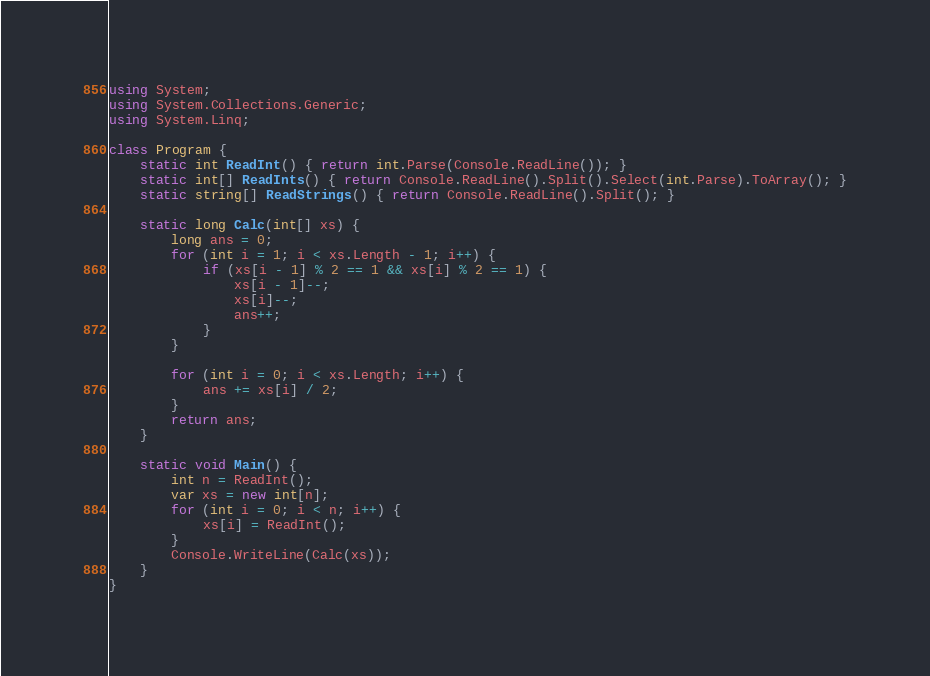<code> <loc_0><loc_0><loc_500><loc_500><_C#_>using System;
using System.Collections.Generic;
using System.Linq;

class Program {
    static int ReadInt() { return int.Parse(Console.ReadLine()); }
    static int[] ReadInts() { return Console.ReadLine().Split().Select(int.Parse).ToArray(); }
    static string[] ReadStrings() { return Console.ReadLine().Split(); }

    static long Calc(int[] xs) {
        long ans = 0;
        for (int i = 1; i < xs.Length - 1; i++) {
            if (xs[i - 1] % 2 == 1 && xs[i] % 2 == 1) {
                xs[i - 1]--;
                xs[i]--;
                ans++;
            }
        }

        for (int i = 0; i < xs.Length; i++) {
            ans += xs[i] / 2;
        }
        return ans;
    }

    static void Main() {
        int n = ReadInt();
        var xs = new int[n];
        for (int i = 0; i < n; i++) {
            xs[i] = ReadInt();
        }
        Console.WriteLine(Calc(xs));
    }
}</code> 